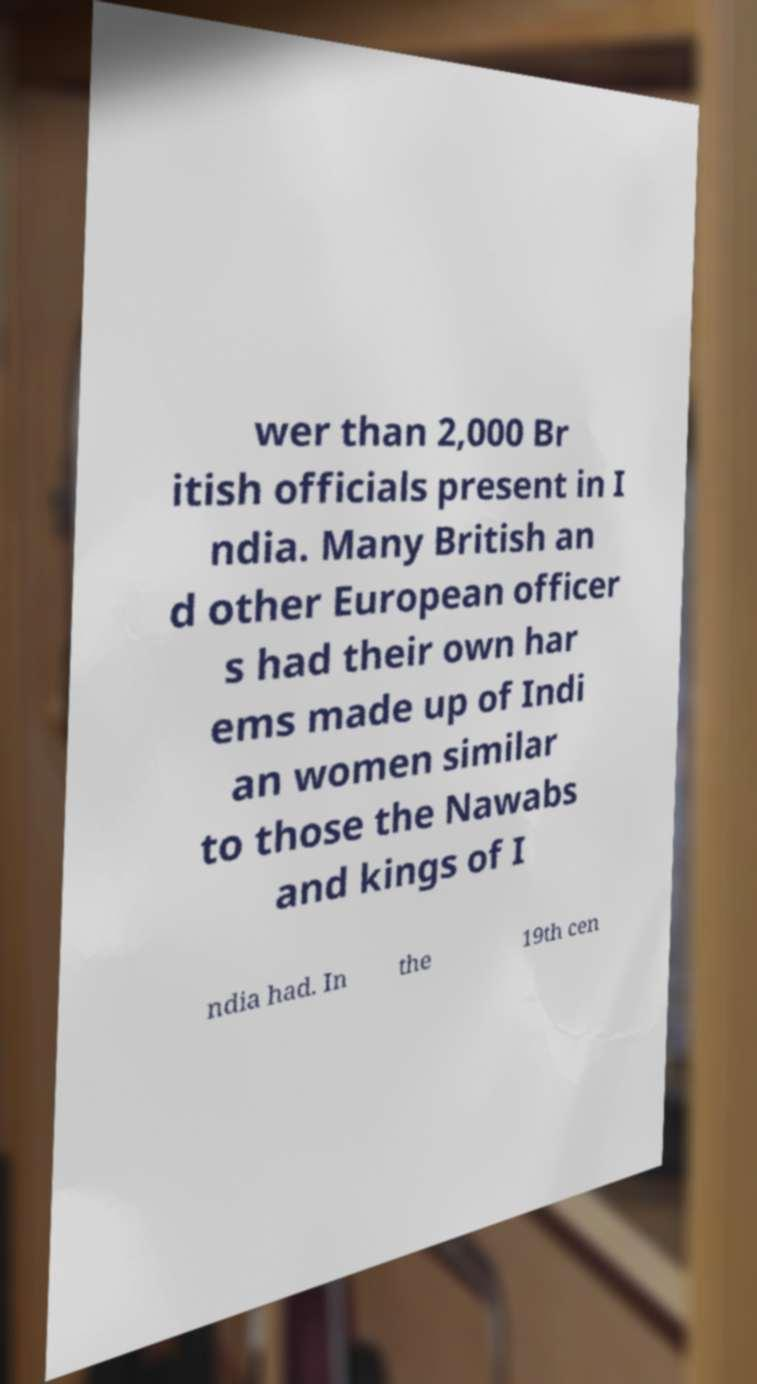Could you extract and type out the text from this image? wer than 2,000 Br itish officials present in I ndia. Many British an d other European officer s had their own har ems made up of Indi an women similar to those the Nawabs and kings of I ndia had. In the 19th cen 